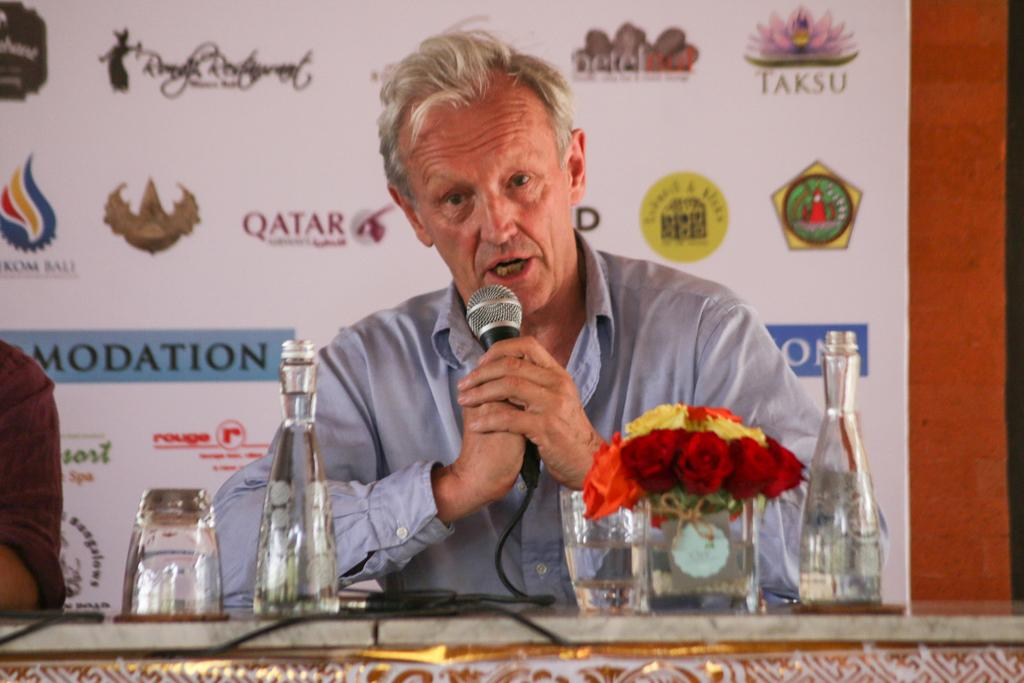<image>
Present a compact description of the photo's key features. A man sits at a table speaking into a microphone with different logos behind him, including that of Taksu and Qatar. 